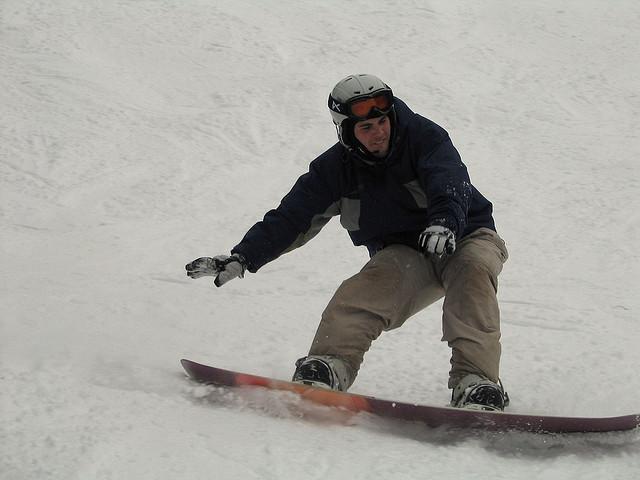How many boats are there?
Give a very brief answer. 0. 